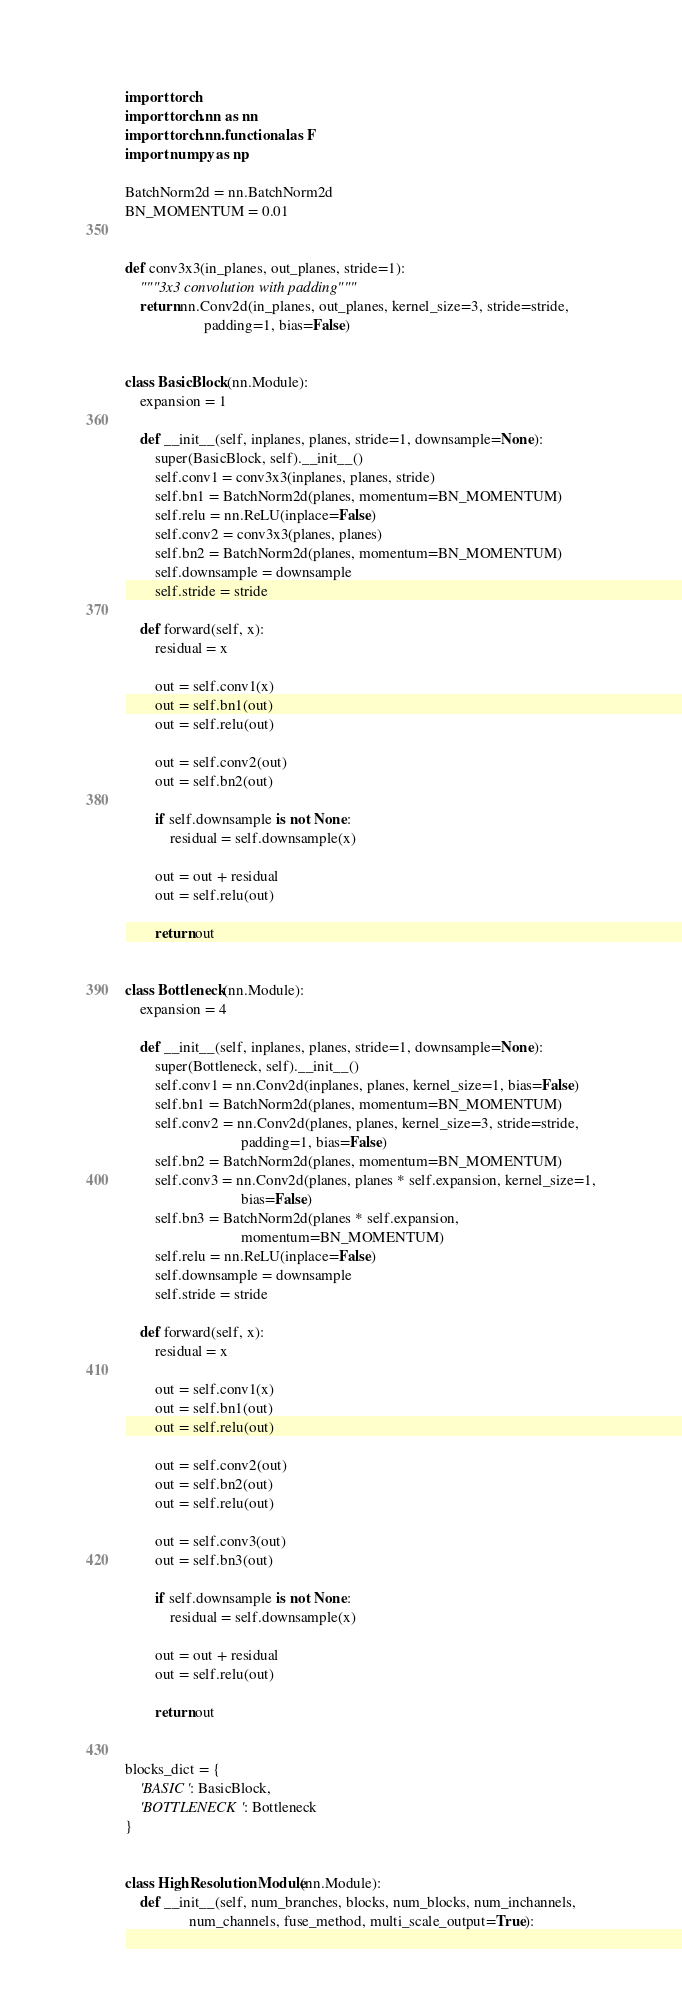Convert code to text. <code><loc_0><loc_0><loc_500><loc_500><_Python_>import torch
import torch.nn as nn
import torch.nn.functional as F
import numpy as np

BatchNorm2d = nn.BatchNorm2d
BN_MOMENTUM = 0.01


def conv3x3(in_planes, out_planes, stride=1):
    """3x3 convolution with padding"""
    return nn.Conv2d(in_planes, out_planes, kernel_size=3, stride=stride,
                     padding=1, bias=False)


class BasicBlock(nn.Module):
    expansion = 1

    def __init__(self, inplanes, planes, stride=1, downsample=None):
        super(BasicBlock, self).__init__()
        self.conv1 = conv3x3(inplanes, planes, stride)
        self.bn1 = BatchNorm2d(planes, momentum=BN_MOMENTUM)
        self.relu = nn.ReLU(inplace=False)
        self.conv2 = conv3x3(planes, planes)
        self.bn2 = BatchNorm2d(planes, momentum=BN_MOMENTUM)
        self.downsample = downsample
        self.stride = stride

    def forward(self, x):
        residual = x

        out = self.conv1(x)
        out = self.bn1(out)
        out = self.relu(out)

        out = self.conv2(out)
        out = self.bn2(out)

        if self.downsample is not None:
            residual = self.downsample(x)

        out = out + residual
        out = self.relu(out)

        return out


class Bottleneck(nn.Module):
    expansion = 4

    def __init__(self, inplanes, planes, stride=1, downsample=None):
        super(Bottleneck, self).__init__()
        self.conv1 = nn.Conv2d(inplanes, planes, kernel_size=1, bias=False)
        self.bn1 = BatchNorm2d(planes, momentum=BN_MOMENTUM)
        self.conv2 = nn.Conv2d(planes, planes, kernel_size=3, stride=stride,
                               padding=1, bias=False)
        self.bn2 = BatchNorm2d(planes, momentum=BN_MOMENTUM)
        self.conv3 = nn.Conv2d(planes, planes * self.expansion, kernel_size=1,
                               bias=False)
        self.bn3 = BatchNorm2d(planes * self.expansion,
                               momentum=BN_MOMENTUM)
        self.relu = nn.ReLU(inplace=False)
        self.downsample = downsample
        self.stride = stride

    def forward(self, x):
        residual = x

        out = self.conv1(x)
        out = self.bn1(out)
        out = self.relu(out)

        out = self.conv2(out)
        out = self.bn2(out)
        out = self.relu(out)

        out = self.conv3(out)
        out = self.bn3(out)

        if self.downsample is not None:
            residual = self.downsample(x)

        out = out + residual
        out = self.relu(out)

        return out


blocks_dict = {
    'BASIC': BasicBlock,
    'BOTTLENECK': Bottleneck
}


class HighResolutionModule(nn.Module):
    def __init__(self, num_branches, blocks, num_blocks, num_inchannels,
                 num_channels, fuse_method, multi_scale_output=True):</code> 